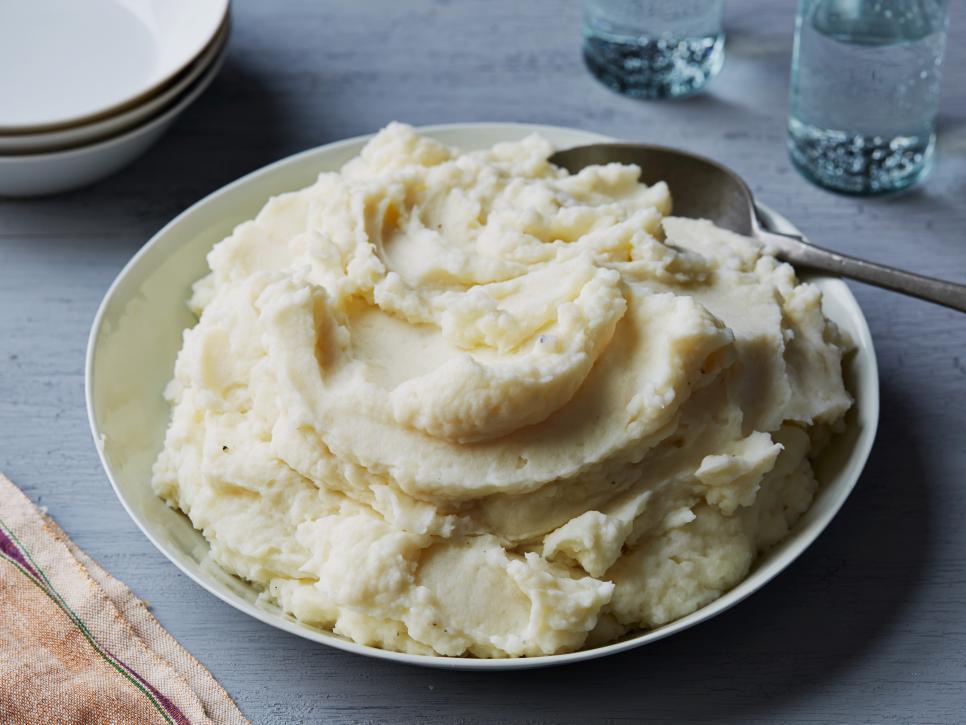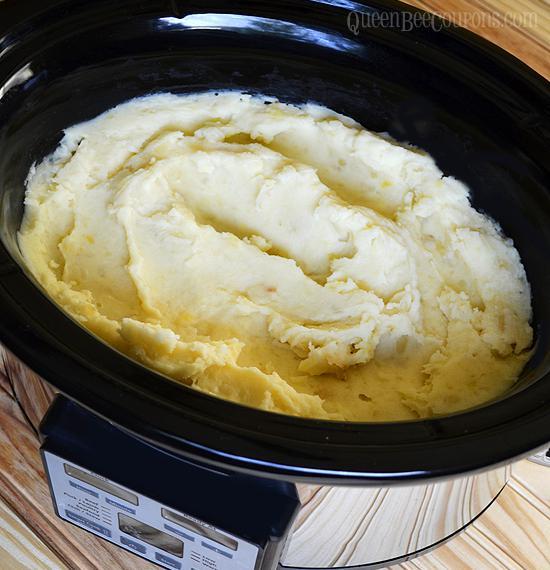The first image is the image on the left, the second image is the image on the right. For the images displayed, is the sentence "A spoon is in a bowl of mashed potatoes in one image." factually correct? Answer yes or no. Yes. The first image is the image on the left, the second image is the image on the right. Examine the images to the left and right. Is the description "In one image, there is a spoon in the mashed potatoes that is resting on the side of the container that the potatoes are in." accurate? Answer yes or no. Yes. 